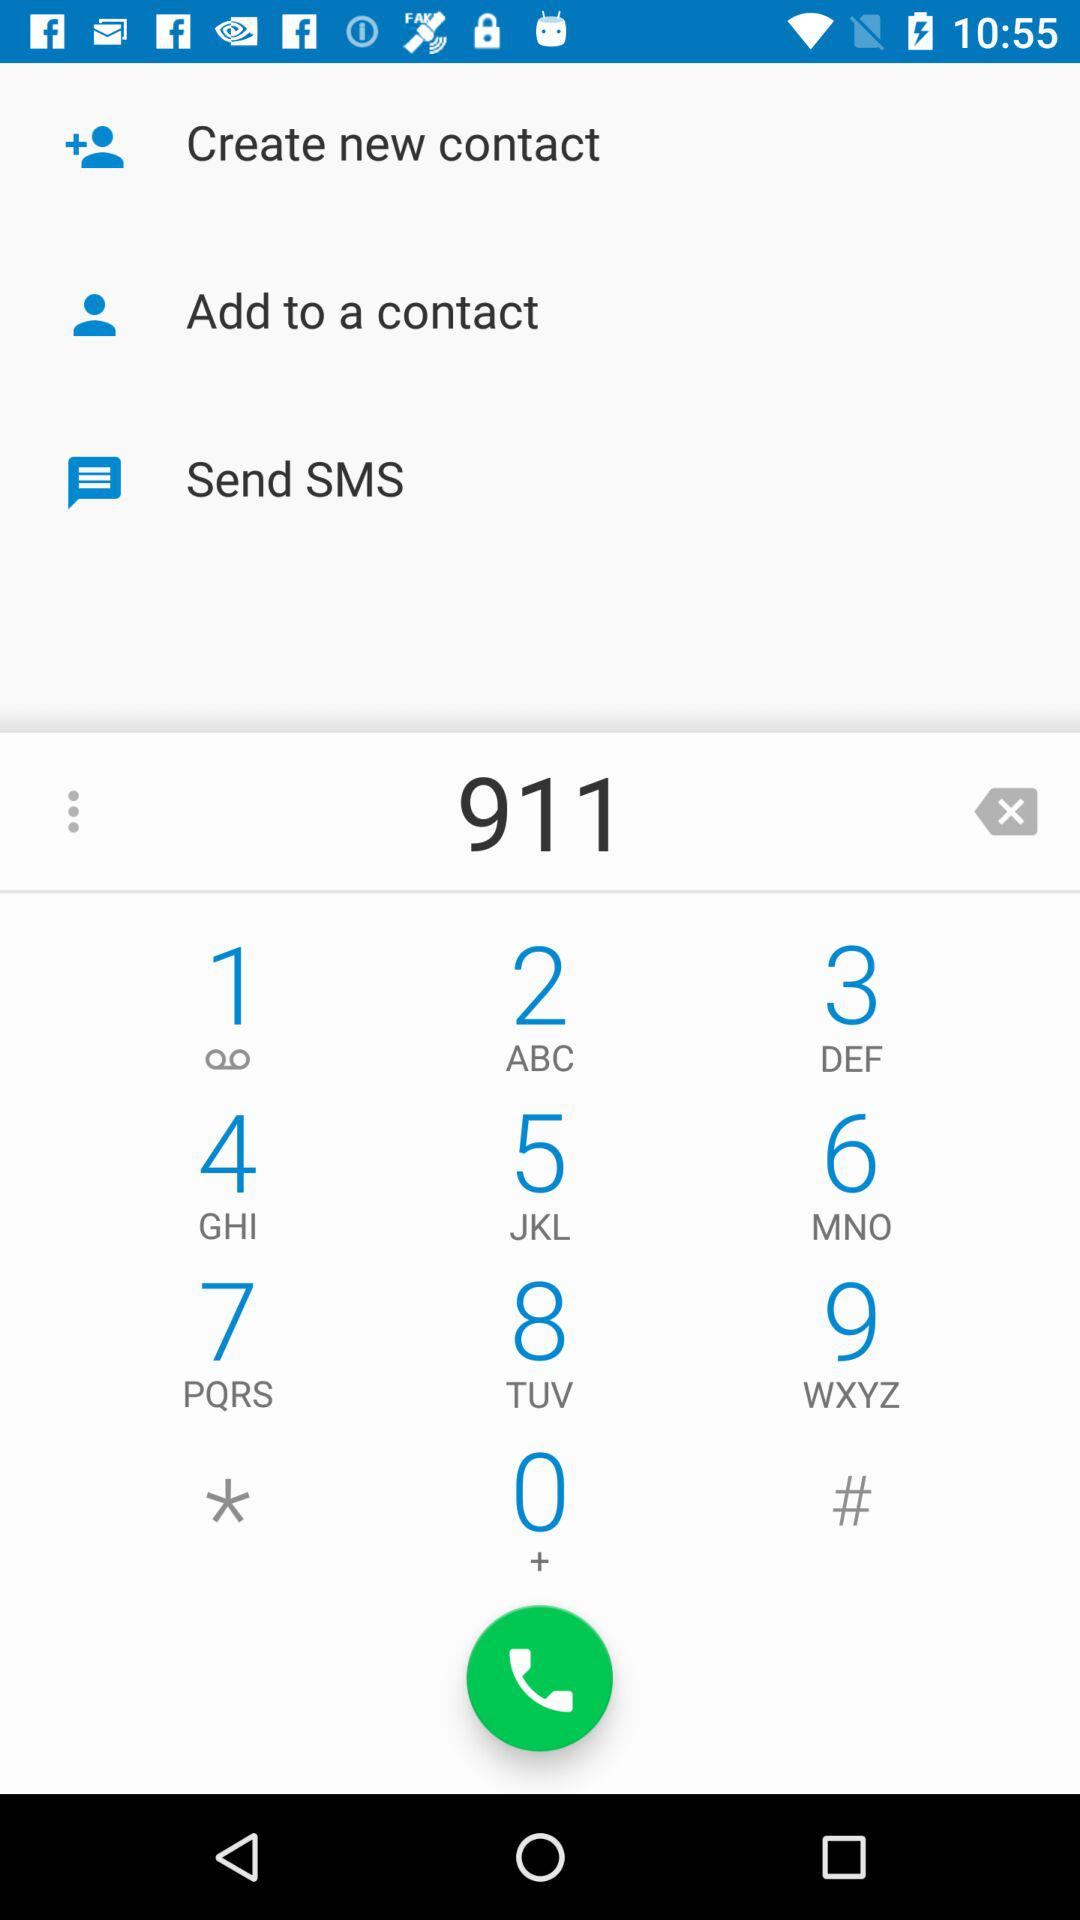What's the input call number? The input call number is 911. 